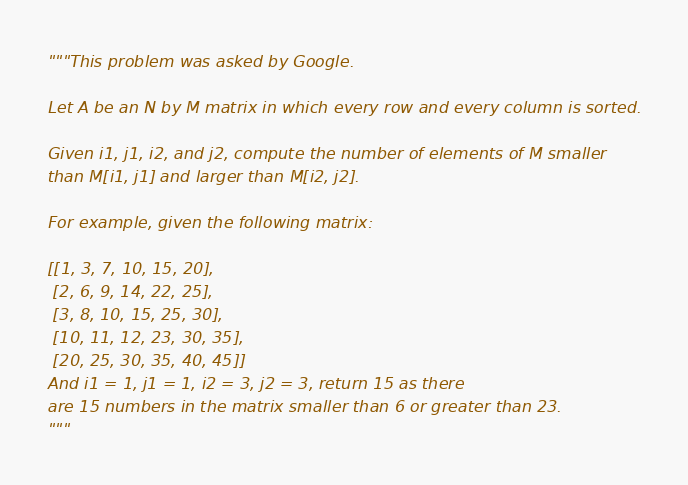<code> <loc_0><loc_0><loc_500><loc_500><_Python_>"""This problem was asked by Google.

Let A be an N by M matrix in which every row and every column is sorted.

Given i1, j1, i2, and j2, compute the number of elements of M smaller 
than M[i1, j1] and larger than M[i2, j2].

For example, given the following matrix:

[[1, 3, 7, 10, 15, 20],
 [2, 6, 9, 14, 22, 25],
 [3, 8, 10, 15, 25, 30],
 [10, 11, 12, 23, 30, 35],
 [20, 25, 30, 35, 40, 45]]
And i1 = 1, j1 = 1, i2 = 3, j2 = 3, return 15 as there 
are 15 numbers in the matrix smaller than 6 or greater than 23.
"""</code> 